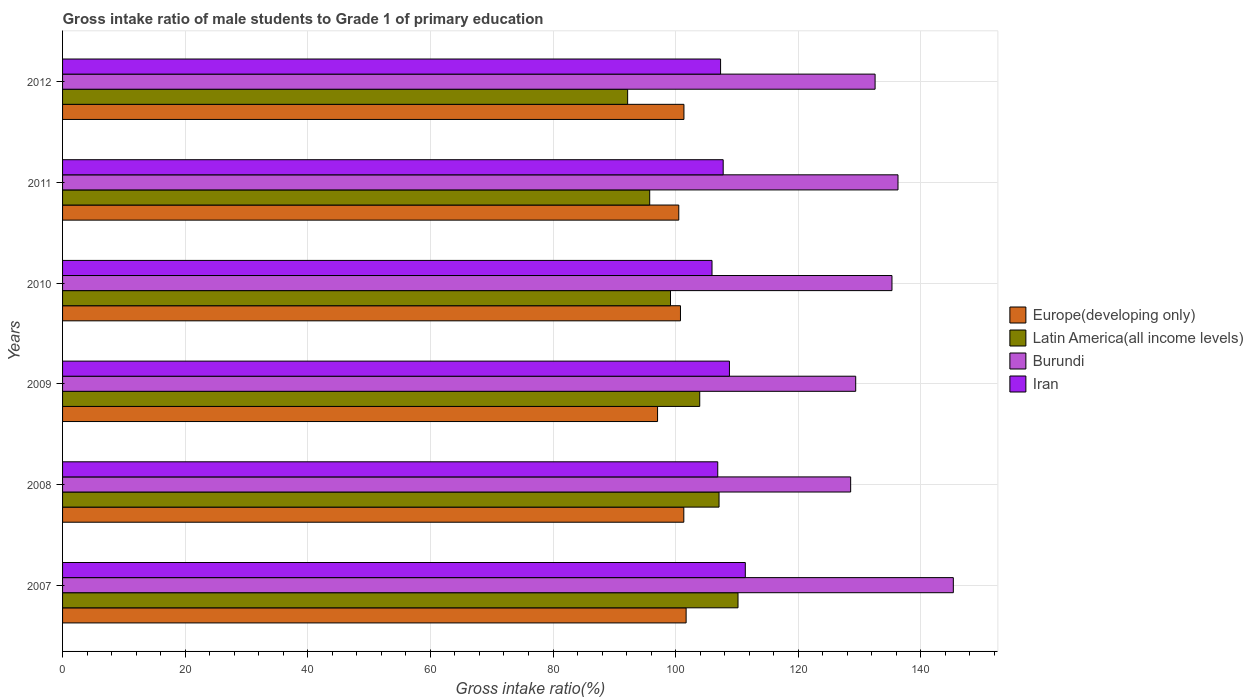How many different coloured bars are there?
Offer a terse response. 4. How many bars are there on the 2nd tick from the top?
Keep it short and to the point. 4. How many bars are there on the 3rd tick from the bottom?
Your answer should be very brief. 4. What is the gross intake ratio in Iran in 2009?
Your answer should be very brief. 108.78. Across all years, what is the maximum gross intake ratio in Latin America(all income levels)?
Give a very brief answer. 110.18. Across all years, what is the minimum gross intake ratio in Europe(developing only)?
Offer a very short reply. 97.05. In which year was the gross intake ratio in Latin America(all income levels) maximum?
Make the answer very short. 2007. What is the total gross intake ratio in Latin America(all income levels) in the graph?
Ensure brevity in your answer.  608.3. What is the difference between the gross intake ratio in Latin America(all income levels) in 2007 and that in 2011?
Give a very brief answer. 14.4. What is the difference between the gross intake ratio in Europe(developing only) in 2010 and the gross intake ratio in Iran in 2008?
Your answer should be compact. -6.08. What is the average gross intake ratio in Europe(developing only) per year?
Provide a succinct answer. 100.46. In the year 2007, what is the difference between the gross intake ratio in Europe(developing only) and gross intake ratio in Burundi?
Offer a very short reply. -43.58. What is the ratio of the gross intake ratio in Latin America(all income levels) in 2007 to that in 2008?
Offer a terse response. 1.03. What is the difference between the highest and the second highest gross intake ratio in Iran?
Provide a succinct answer. 2.59. What is the difference between the highest and the lowest gross intake ratio in Latin America(all income levels)?
Your response must be concise. 18. In how many years, is the gross intake ratio in Burundi greater than the average gross intake ratio in Burundi taken over all years?
Give a very brief answer. 3. Is the sum of the gross intake ratio in Latin America(all income levels) in 2007 and 2009 greater than the maximum gross intake ratio in Burundi across all years?
Your response must be concise. Yes. What does the 4th bar from the top in 2008 represents?
Provide a succinct answer. Europe(developing only). What does the 1st bar from the bottom in 2010 represents?
Ensure brevity in your answer.  Europe(developing only). Is it the case that in every year, the sum of the gross intake ratio in Burundi and gross intake ratio in Latin America(all income levels) is greater than the gross intake ratio in Europe(developing only)?
Keep it short and to the point. Yes. How many bars are there?
Ensure brevity in your answer.  24. Are the values on the major ticks of X-axis written in scientific E-notation?
Offer a very short reply. No. Does the graph contain grids?
Your answer should be very brief. Yes. How are the legend labels stacked?
Provide a short and direct response. Vertical. What is the title of the graph?
Your answer should be very brief. Gross intake ratio of male students to Grade 1 of primary education. Does "St. Lucia" appear as one of the legend labels in the graph?
Offer a very short reply. No. What is the label or title of the X-axis?
Offer a terse response. Gross intake ratio(%). What is the Gross intake ratio(%) in Europe(developing only) in 2007?
Provide a short and direct response. 101.71. What is the Gross intake ratio(%) of Latin America(all income levels) in 2007?
Offer a very short reply. 110.18. What is the Gross intake ratio(%) of Burundi in 2007?
Offer a very short reply. 145.3. What is the Gross intake ratio(%) of Iran in 2007?
Make the answer very short. 111.37. What is the Gross intake ratio(%) of Europe(developing only) in 2008?
Your answer should be very brief. 101.34. What is the Gross intake ratio(%) in Latin America(all income levels) in 2008?
Your answer should be very brief. 107.08. What is the Gross intake ratio(%) in Burundi in 2008?
Ensure brevity in your answer.  128.55. What is the Gross intake ratio(%) of Iran in 2008?
Your answer should be very brief. 106.87. What is the Gross intake ratio(%) in Europe(developing only) in 2009?
Your response must be concise. 97.05. What is the Gross intake ratio(%) in Latin America(all income levels) in 2009?
Ensure brevity in your answer.  103.93. What is the Gross intake ratio(%) in Burundi in 2009?
Make the answer very short. 129.37. What is the Gross intake ratio(%) in Iran in 2009?
Your response must be concise. 108.78. What is the Gross intake ratio(%) in Europe(developing only) in 2010?
Ensure brevity in your answer.  100.79. What is the Gross intake ratio(%) of Latin America(all income levels) in 2010?
Ensure brevity in your answer.  99.16. What is the Gross intake ratio(%) in Burundi in 2010?
Offer a terse response. 135.29. What is the Gross intake ratio(%) of Iran in 2010?
Give a very brief answer. 105.94. What is the Gross intake ratio(%) in Europe(developing only) in 2011?
Provide a short and direct response. 100.51. What is the Gross intake ratio(%) of Latin America(all income levels) in 2011?
Make the answer very short. 95.77. What is the Gross intake ratio(%) of Burundi in 2011?
Your response must be concise. 136.27. What is the Gross intake ratio(%) in Iran in 2011?
Provide a short and direct response. 107.76. What is the Gross intake ratio(%) of Europe(developing only) in 2012?
Keep it short and to the point. 101.36. What is the Gross intake ratio(%) in Latin America(all income levels) in 2012?
Make the answer very short. 92.17. What is the Gross intake ratio(%) of Burundi in 2012?
Offer a terse response. 132.54. What is the Gross intake ratio(%) in Iran in 2012?
Your answer should be compact. 107.33. Across all years, what is the maximum Gross intake ratio(%) of Europe(developing only)?
Offer a very short reply. 101.71. Across all years, what is the maximum Gross intake ratio(%) in Latin America(all income levels)?
Offer a terse response. 110.18. Across all years, what is the maximum Gross intake ratio(%) of Burundi?
Your response must be concise. 145.3. Across all years, what is the maximum Gross intake ratio(%) of Iran?
Your answer should be compact. 111.37. Across all years, what is the minimum Gross intake ratio(%) of Europe(developing only)?
Give a very brief answer. 97.05. Across all years, what is the minimum Gross intake ratio(%) in Latin America(all income levels)?
Offer a terse response. 92.17. Across all years, what is the minimum Gross intake ratio(%) of Burundi?
Give a very brief answer. 128.55. Across all years, what is the minimum Gross intake ratio(%) in Iran?
Your answer should be compact. 105.94. What is the total Gross intake ratio(%) in Europe(developing only) in the graph?
Provide a succinct answer. 602.77. What is the total Gross intake ratio(%) in Latin America(all income levels) in the graph?
Give a very brief answer. 608.3. What is the total Gross intake ratio(%) of Burundi in the graph?
Your answer should be very brief. 807.32. What is the total Gross intake ratio(%) in Iran in the graph?
Your answer should be compact. 648.04. What is the difference between the Gross intake ratio(%) in Europe(developing only) in 2007 and that in 2008?
Your answer should be compact. 0.38. What is the difference between the Gross intake ratio(%) in Latin America(all income levels) in 2007 and that in 2008?
Give a very brief answer. 3.1. What is the difference between the Gross intake ratio(%) of Burundi in 2007 and that in 2008?
Give a very brief answer. 16.75. What is the difference between the Gross intake ratio(%) of Iran in 2007 and that in 2008?
Your answer should be compact. 4.5. What is the difference between the Gross intake ratio(%) in Europe(developing only) in 2007 and that in 2009?
Your response must be concise. 4.66. What is the difference between the Gross intake ratio(%) in Latin America(all income levels) in 2007 and that in 2009?
Your answer should be very brief. 6.25. What is the difference between the Gross intake ratio(%) in Burundi in 2007 and that in 2009?
Your answer should be compact. 15.92. What is the difference between the Gross intake ratio(%) of Iran in 2007 and that in 2009?
Keep it short and to the point. 2.59. What is the difference between the Gross intake ratio(%) in Europe(developing only) in 2007 and that in 2010?
Offer a very short reply. 0.92. What is the difference between the Gross intake ratio(%) of Latin America(all income levels) in 2007 and that in 2010?
Provide a short and direct response. 11.01. What is the difference between the Gross intake ratio(%) in Burundi in 2007 and that in 2010?
Provide a succinct answer. 10.01. What is the difference between the Gross intake ratio(%) in Iran in 2007 and that in 2010?
Offer a terse response. 5.43. What is the difference between the Gross intake ratio(%) in Europe(developing only) in 2007 and that in 2011?
Provide a succinct answer. 1.2. What is the difference between the Gross intake ratio(%) of Latin America(all income levels) in 2007 and that in 2011?
Offer a terse response. 14.4. What is the difference between the Gross intake ratio(%) in Burundi in 2007 and that in 2011?
Give a very brief answer. 9.03. What is the difference between the Gross intake ratio(%) of Iran in 2007 and that in 2011?
Keep it short and to the point. 3.61. What is the difference between the Gross intake ratio(%) of Europe(developing only) in 2007 and that in 2012?
Provide a short and direct response. 0.36. What is the difference between the Gross intake ratio(%) of Latin America(all income levels) in 2007 and that in 2012?
Keep it short and to the point. 18. What is the difference between the Gross intake ratio(%) of Burundi in 2007 and that in 2012?
Your response must be concise. 12.76. What is the difference between the Gross intake ratio(%) in Iran in 2007 and that in 2012?
Keep it short and to the point. 4.03. What is the difference between the Gross intake ratio(%) in Europe(developing only) in 2008 and that in 2009?
Keep it short and to the point. 4.28. What is the difference between the Gross intake ratio(%) of Latin America(all income levels) in 2008 and that in 2009?
Keep it short and to the point. 3.15. What is the difference between the Gross intake ratio(%) of Burundi in 2008 and that in 2009?
Make the answer very short. -0.82. What is the difference between the Gross intake ratio(%) in Iran in 2008 and that in 2009?
Your answer should be very brief. -1.91. What is the difference between the Gross intake ratio(%) in Europe(developing only) in 2008 and that in 2010?
Offer a terse response. 0.54. What is the difference between the Gross intake ratio(%) in Latin America(all income levels) in 2008 and that in 2010?
Your answer should be compact. 7.92. What is the difference between the Gross intake ratio(%) of Burundi in 2008 and that in 2010?
Offer a very short reply. -6.74. What is the difference between the Gross intake ratio(%) in Iran in 2008 and that in 2010?
Keep it short and to the point. 0.93. What is the difference between the Gross intake ratio(%) in Europe(developing only) in 2008 and that in 2011?
Make the answer very short. 0.82. What is the difference between the Gross intake ratio(%) in Latin America(all income levels) in 2008 and that in 2011?
Your response must be concise. 11.31. What is the difference between the Gross intake ratio(%) in Burundi in 2008 and that in 2011?
Your answer should be very brief. -7.72. What is the difference between the Gross intake ratio(%) in Iran in 2008 and that in 2011?
Provide a succinct answer. -0.89. What is the difference between the Gross intake ratio(%) of Europe(developing only) in 2008 and that in 2012?
Keep it short and to the point. -0.02. What is the difference between the Gross intake ratio(%) of Latin America(all income levels) in 2008 and that in 2012?
Provide a short and direct response. 14.91. What is the difference between the Gross intake ratio(%) in Burundi in 2008 and that in 2012?
Provide a succinct answer. -3.99. What is the difference between the Gross intake ratio(%) in Iran in 2008 and that in 2012?
Your answer should be very brief. -0.46. What is the difference between the Gross intake ratio(%) in Europe(developing only) in 2009 and that in 2010?
Your answer should be compact. -3.74. What is the difference between the Gross intake ratio(%) of Latin America(all income levels) in 2009 and that in 2010?
Keep it short and to the point. 4.77. What is the difference between the Gross intake ratio(%) in Burundi in 2009 and that in 2010?
Offer a terse response. -5.92. What is the difference between the Gross intake ratio(%) in Iran in 2009 and that in 2010?
Make the answer very short. 2.84. What is the difference between the Gross intake ratio(%) in Europe(developing only) in 2009 and that in 2011?
Keep it short and to the point. -3.46. What is the difference between the Gross intake ratio(%) in Latin America(all income levels) in 2009 and that in 2011?
Provide a succinct answer. 8.16. What is the difference between the Gross intake ratio(%) of Burundi in 2009 and that in 2011?
Offer a very short reply. -6.9. What is the difference between the Gross intake ratio(%) of Iran in 2009 and that in 2011?
Your answer should be very brief. 1.02. What is the difference between the Gross intake ratio(%) in Europe(developing only) in 2009 and that in 2012?
Offer a terse response. -4.3. What is the difference between the Gross intake ratio(%) in Latin America(all income levels) in 2009 and that in 2012?
Your answer should be compact. 11.76. What is the difference between the Gross intake ratio(%) of Burundi in 2009 and that in 2012?
Provide a succinct answer. -3.16. What is the difference between the Gross intake ratio(%) of Iran in 2009 and that in 2012?
Keep it short and to the point. 1.45. What is the difference between the Gross intake ratio(%) in Europe(developing only) in 2010 and that in 2011?
Ensure brevity in your answer.  0.28. What is the difference between the Gross intake ratio(%) in Latin America(all income levels) in 2010 and that in 2011?
Provide a short and direct response. 3.39. What is the difference between the Gross intake ratio(%) in Burundi in 2010 and that in 2011?
Your answer should be very brief. -0.98. What is the difference between the Gross intake ratio(%) of Iran in 2010 and that in 2011?
Offer a terse response. -1.82. What is the difference between the Gross intake ratio(%) in Europe(developing only) in 2010 and that in 2012?
Ensure brevity in your answer.  -0.57. What is the difference between the Gross intake ratio(%) in Latin America(all income levels) in 2010 and that in 2012?
Offer a very short reply. 6.99. What is the difference between the Gross intake ratio(%) in Burundi in 2010 and that in 2012?
Give a very brief answer. 2.75. What is the difference between the Gross intake ratio(%) in Iran in 2010 and that in 2012?
Ensure brevity in your answer.  -1.4. What is the difference between the Gross intake ratio(%) in Europe(developing only) in 2011 and that in 2012?
Ensure brevity in your answer.  -0.84. What is the difference between the Gross intake ratio(%) of Latin America(all income levels) in 2011 and that in 2012?
Make the answer very short. 3.6. What is the difference between the Gross intake ratio(%) of Burundi in 2011 and that in 2012?
Keep it short and to the point. 3.74. What is the difference between the Gross intake ratio(%) of Iran in 2011 and that in 2012?
Your answer should be very brief. 0.43. What is the difference between the Gross intake ratio(%) of Europe(developing only) in 2007 and the Gross intake ratio(%) of Latin America(all income levels) in 2008?
Offer a very short reply. -5.37. What is the difference between the Gross intake ratio(%) of Europe(developing only) in 2007 and the Gross intake ratio(%) of Burundi in 2008?
Provide a short and direct response. -26.84. What is the difference between the Gross intake ratio(%) in Europe(developing only) in 2007 and the Gross intake ratio(%) in Iran in 2008?
Offer a very short reply. -5.16. What is the difference between the Gross intake ratio(%) of Latin America(all income levels) in 2007 and the Gross intake ratio(%) of Burundi in 2008?
Your answer should be compact. -18.37. What is the difference between the Gross intake ratio(%) in Latin America(all income levels) in 2007 and the Gross intake ratio(%) in Iran in 2008?
Provide a short and direct response. 3.31. What is the difference between the Gross intake ratio(%) of Burundi in 2007 and the Gross intake ratio(%) of Iran in 2008?
Give a very brief answer. 38.43. What is the difference between the Gross intake ratio(%) in Europe(developing only) in 2007 and the Gross intake ratio(%) in Latin America(all income levels) in 2009?
Provide a short and direct response. -2.22. What is the difference between the Gross intake ratio(%) in Europe(developing only) in 2007 and the Gross intake ratio(%) in Burundi in 2009?
Ensure brevity in your answer.  -27.66. What is the difference between the Gross intake ratio(%) of Europe(developing only) in 2007 and the Gross intake ratio(%) of Iran in 2009?
Your response must be concise. -7.07. What is the difference between the Gross intake ratio(%) of Latin America(all income levels) in 2007 and the Gross intake ratio(%) of Burundi in 2009?
Your answer should be very brief. -19.2. What is the difference between the Gross intake ratio(%) in Latin America(all income levels) in 2007 and the Gross intake ratio(%) in Iran in 2009?
Give a very brief answer. 1.4. What is the difference between the Gross intake ratio(%) in Burundi in 2007 and the Gross intake ratio(%) in Iran in 2009?
Your response must be concise. 36.52. What is the difference between the Gross intake ratio(%) of Europe(developing only) in 2007 and the Gross intake ratio(%) of Latin America(all income levels) in 2010?
Provide a succinct answer. 2.55. What is the difference between the Gross intake ratio(%) of Europe(developing only) in 2007 and the Gross intake ratio(%) of Burundi in 2010?
Offer a very short reply. -33.58. What is the difference between the Gross intake ratio(%) in Europe(developing only) in 2007 and the Gross intake ratio(%) in Iran in 2010?
Your response must be concise. -4.22. What is the difference between the Gross intake ratio(%) in Latin America(all income levels) in 2007 and the Gross intake ratio(%) in Burundi in 2010?
Keep it short and to the point. -25.11. What is the difference between the Gross intake ratio(%) in Latin America(all income levels) in 2007 and the Gross intake ratio(%) in Iran in 2010?
Give a very brief answer. 4.24. What is the difference between the Gross intake ratio(%) in Burundi in 2007 and the Gross intake ratio(%) in Iran in 2010?
Ensure brevity in your answer.  39.36. What is the difference between the Gross intake ratio(%) of Europe(developing only) in 2007 and the Gross intake ratio(%) of Latin America(all income levels) in 2011?
Offer a very short reply. 5.94. What is the difference between the Gross intake ratio(%) of Europe(developing only) in 2007 and the Gross intake ratio(%) of Burundi in 2011?
Give a very brief answer. -34.56. What is the difference between the Gross intake ratio(%) of Europe(developing only) in 2007 and the Gross intake ratio(%) of Iran in 2011?
Keep it short and to the point. -6.05. What is the difference between the Gross intake ratio(%) in Latin America(all income levels) in 2007 and the Gross intake ratio(%) in Burundi in 2011?
Ensure brevity in your answer.  -26.1. What is the difference between the Gross intake ratio(%) in Latin America(all income levels) in 2007 and the Gross intake ratio(%) in Iran in 2011?
Ensure brevity in your answer.  2.42. What is the difference between the Gross intake ratio(%) in Burundi in 2007 and the Gross intake ratio(%) in Iran in 2011?
Keep it short and to the point. 37.54. What is the difference between the Gross intake ratio(%) in Europe(developing only) in 2007 and the Gross intake ratio(%) in Latin America(all income levels) in 2012?
Your response must be concise. 9.54. What is the difference between the Gross intake ratio(%) of Europe(developing only) in 2007 and the Gross intake ratio(%) of Burundi in 2012?
Keep it short and to the point. -30.82. What is the difference between the Gross intake ratio(%) of Europe(developing only) in 2007 and the Gross intake ratio(%) of Iran in 2012?
Keep it short and to the point. -5.62. What is the difference between the Gross intake ratio(%) in Latin America(all income levels) in 2007 and the Gross intake ratio(%) in Burundi in 2012?
Your answer should be compact. -22.36. What is the difference between the Gross intake ratio(%) in Latin America(all income levels) in 2007 and the Gross intake ratio(%) in Iran in 2012?
Your response must be concise. 2.85. What is the difference between the Gross intake ratio(%) in Burundi in 2007 and the Gross intake ratio(%) in Iran in 2012?
Offer a terse response. 37.97. What is the difference between the Gross intake ratio(%) in Europe(developing only) in 2008 and the Gross intake ratio(%) in Latin America(all income levels) in 2009?
Keep it short and to the point. -2.6. What is the difference between the Gross intake ratio(%) of Europe(developing only) in 2008 and the Gross intake ratio(%) of Burundi in 2009?
Offer a very short reply. -28.04. What is the difference between the Gross intake ratio(%) in Europe(developing only) in 2008 and the Gross intake ratio(%) in Iran in 2009?
Provide a succinct answer. -7.44. What is the difference between the Gross intake ratio(%) of Latin America(all income levels) in 2008 and the Gross intake ratio(%) of Burundi in 2009?
Offer a very short reply. -22.29. What is the difference between the Gross intake ratio(%) of Latin America(all income levels) in 2008 and the Gross intake ratio(%) of Iran in 2009?
Your response must be concise. -1.7. What is the difference between the Gross intake ratio(%) of Burundi in 2008 and the Gross intake ratio(%) of Iran in 2009?
Ensure brevity in your answer.  19.77. What is the difference between the Gross intake ratio(%) of Europe(developing only) in 2008 and the Gross intake ratio(%) of Latin America(all income levels) in 2010?
Your response must be concise. 2.17. What is the difference between the Gross intake ratio(%) in Europe(developing only) in 2008 and the Gross intake ratio(%) in Burundi in 2010?
Ensure brevity in your answer.  -33.95. What is the difference between the Gross intake ratio(%) of Europe(developing only) in 2008 and the Gross intake ratio(%) of Iran in 2010?
Offer a terse response. -4.6. What is the difference between the Gross intake ratio(%) of Latin America(all income levels) in 2008 and the Gross intake ratio(%) of Burundi in 2010?
Your response must be concise. -28.21. What is the difference between the Gross intake ratio(%) of Latin America(all income levels) in 2008 and the Gross intake ratio(%) of Iran in 2010?
Make the answer very short. 1.15. What is the difference between the Gross intake ratio(%) of Burundi in 2008 and the Gross intake ratio(%) of Iran in 2010?
Offer a terse response. 22.61. What is the difference between the Gross intake ratio(%) of Europe(developing only) in 2008 and the Gross intake ratio(%) of Latin America(all income levels) in 2011?
Offer a very short reply. 5.56. What is the difference between the Gross intake ratio(%) in Europe(developing only) in 2008 and the Gross intake ratio(%) in Burundi in 2011?
Provide a succinct answer. -34.94. What is the difference between the Gross intake ratio(%) of Europe(developing only) in 2008 and the Gross intake ratio(%) of Iran in 2011?
Offer a terse response. -6.42. What is the difference between the Gross intake ratio(%) in Latin America(all income levels) in 2008 and the Gross intake ratio(%) in Burundi in 2011?
Ensure brevity in your answer.  -29.19. What is the difference between the Gross intake ratio(%) of Latin America(all income levels) in 2008 and the Gross intake ratio(%) of Iran in 2011?
Offer a terse response. -0.68. What is the difference between the Gross intake ratio(%) of Burundi in 2008 and the Gross intake ratio(%) of Iran in 2011?
Make the answer very short. 20.79. What is the difference between the Gross intake ratio(%) in Europe(developing only) in 2008 and the Gross intake ratio(%) in Latin America(all income levels) in 2012?
Give a very brief answer. 9.16. What is the difference between the Gross intake ratio(%) in Europe(developing only) in 2008 and the Gross intake ratio(%) in Burundi in 2012?
Your answer should be compact. -31.2. What is the difference between the Gross intake ratio(%) of Europe(developing only) in 2008 and the Gross intake ratio(%) of Iran in 2012?
Keep it short and to the point. -6. What is the difference between the Gross intake ratio(%) of Latin America(all income levels) in 2008 and the Gross intake ratio(%) of Burundi in 2012?
Make the answer very short. -25.46. What is the difference between the Gross intake ratio(%) in Latin America(all income levels) in 2008 and the Gross intake ratio(%) in Iran in 2012?
Provide a succinct answer. -0.25. What is the difference between the Gross intake ratio(%) of Burundi in 2008 and the Gross intake ratio(%) of Iran in 2012?
Your answer should be compact. 21.22. What is the difference between the Gross intake ratio(%) of Europe(developing only) in 2009 and the Gross intake ratio(%) of Latin America(all income levels) in 2010?
Provide a succinct answer. -2.11. What is the difference between the Gross intake ratio(%) in Europe(developing only) in 2009 and the Gross intake ratio(%) in Burundi in 2010?
Your answer should be very brief. -38.24. What is the difference between the Gross intake ratio(%) in Europe(developing only) in 2009 and the Gross intake ratio(%) in Iran in 2010?
Your answer should be compact. -8.88. What is the difference between the Gross intake ratio(%) of Latin America(all income levels) in 2009 and the Gross intake ratio(%) of Burundi in 2010?
Your answer should be very brief. -31.36. What is the difference between the Gross intake ratio(%) of Latin America(all income levels) in 2009 and the Gross intake ratio(%) of Iran in 2010?
Keep it short and to the point. -2. What is the difference between the Gross intake ratio(%) in Burundi in 2009 and the Gross intake ratio(%) in Iran in 2010?
Your answer should be compact. 23.44. What is the difference between the Gross intake ratio(%) in Europe(developing only) in 2009 and the Gross intake ratio(%) in Latin America(all income levels) in 2011?
Ensure brevity in your answer.  1.28. What is the difference between the Gross intake ratio(%) in Europe(developing only) in 2009 and the Gross intake ratio(%) in Burundi in 2011?
Make the answer very short. -39.22. What is the difference between the Gross intake ratio(%) in Europe(developing only) in 2009 and the Gross intake ratio(%) in Iran in 2011?
Provide a succinct answer. -10.7. What is the difference between the Gross intake ratio(%) of Latin America(all income levels) in 2009 and the Gross intake ratio(%) of Burundi in 2011?
Offer a very short reply. -32.34. What is the difference between the Gross intake ratio(%) in Latin America(all income levels) in 2009 and the Gross intake ratio(%) in Iran in 2011?
Make the answer very short. -3.83. What is the difference between the Gross intake ratio(%) in Burundi in 2009 and the Gross intake ratio(%) in Iran in 2011?
Provide a succinct answer. 21.62. What is the difference between the Gross intake ratio(%) of Europe(developing only) in 2009 and the Gross intake ratio(%) of Latin America(all income levels) in 2012?
Provide a short and direct response. 4.88. What is the difference between the Gross intake ratio(%) in Europe(developing only) in 2009 and the Gross intake ratio(%) in Burundi in 2012?
Offer a very short reply. -35.48. What is the difference between the Gross intake ratio(%) of Europe(developing only) in 2009 and the Gross intake ratio(%) of Iran in 2012?
Offer a terse response. -10.28. What is the difference between the Gross intake ratio(%) in Latin America(all income levels) in 2009 and the Gross intake ratio(%) in Burundi in 2012?
Your response must be concise. -28.61. What is the difference between the Gross intake ratio(%) in Latin America(all income levels) in 2009 and the Gross intake ratio(%) in Iran in 2012?
Give a very brief answer. -3.4. What is the difference between the Gross intake ratio(%) of Burundi in 2009 and the Gross intake ratio(%) of Iran in 2012?
Make the answer very short. 22.04. What is the difference between the Gross intake ratio(%) in Europe(developing only) in 2010 and the Gross intake ratio(%) in Latin America(all income levels) in 2011?
Keep it short and to the point. 5.02. What is the difference between the Gross intake ratio(%) of Europe(developing only) in 2010 and the Gross intake ratio(%) of Burundi in 2011?
Ensure brevity in your answer.  -35.48. What is the difference between the Gross intake ratio(%) in Europe(developing only) in 2010 and the Gross intake ratio(%) in Iran in 2011?
Ensure brevity in your answer.  -6.97. What is the difference between the Gross intake ratio(%) in Latin America(all income levels) in 2010 and the Gross intake ratio(%) in Burundi in 2011?
Provide a succinct answer. -37.11. What is the difference between the Gross intake ratio(%) of Latin America(all income levels) in 2010 and the Gross intake ratio(%) of Iran in 2011?
Your response must be concise. -8.59. What is the difference between the Gross intake ratio(%) of Burundi in 2010 and the Gross intake ratio(%) of Iran in 2011?
Offer a terse response. 27.53. What is the difference between the Gross intake ratio(%) of Europe(developing only) in 2010 and the Gross intake ratio(%) of Latin America(all income levels) in 2012?
Your answer should be compact. 8.62. What is the difference between the Gross intake ratio(%) in Europe(developing only) in 2010 and the Gross intake ratio(%) in Burundi in 2012?
Ensure brevity in your answer.  -31.75. What is the difference between the Gross intake ratio(%) in Europe(developing only) in 2010 and the Gross intake ratio(%) in Iran in 2012?
Keep it short and to the point. -6.54. What is the difference between the Gross intake ratio(%) in Latin America(all income levels) in 2010 and the Gross intake ratio(%) in Burundi in 2012?
Keep it short and to the point. -33.37. What is the difference between the Gross intake ratio(%) of Latin America(all income levels) in 2010 and the Gross intake ratio(%) of Iran in 2012?
Your answer should be compact. -8.17. What is the difference between the Gross intake ratio(%) of Burundi in 2010 and the Gross intake ratio(%) of Iran in 2012?
Your answer should be very brief. 27.96. What is the difference between the Gross intake ratio(%) in Europe(developing only) in 2011 and the Gross intake ratio(%) in Latin America(all income levels) in 2012?
Give a very brief answer. 8.34. What is the difference between the Gross intake ratio(%) of Europe(developing only) in 2011 and the Gross intake ratio(%) of Burundi in 2012?
Offer a terse response. -32.02. What is the difference between the Gross intake ratio(%) in Europe(developing only) in 2011 and the Gross intake ratio(%) in Iran in 2012?
Your answer should be very brief. -6.82. What is the difference between the Gross intake ratio(%) of Latin America(all income levels) in 2011 and the Gross intake ratio(%) of Burundi in 2012?
Provide a succinct answer. -36.76. What is the difference between the Gross intake ratio(%) in Latin America(all income levels) in 2011 and the Gross intake ratio(%) in Iran in 2012?
Make the answer very short. -11.56. What is the difference between the Gross intake ratio(%) in Burundi in 2011 and the Gross intake ratio(%) in Iran in 2012?
Keep it short and to the point. 28.94. What is the average Gross intake ratio(%) in Europe(developing only) per year?
Make the answer very short. 100.46. What is the average Gross intake ratio(%) in Latin America(all income levels) per year?
Your answer should be very brief. 101.38. What is the average Gross intake ratio(%) in Burundi per year?
Ensure brevity in your answer.  134.55. What is the average Gross intake ratio(%) of Iran per year?
Provide a short and direct response. 108.01. In the year 2007, what is the difference between the Gross intake ratio(%) in Europe(developing only) and Gross intake ratio(%) in Latin America(all income levels)?
Your answer should be compact. -8.46. In the year 2007, what is the difference between the Gross intake ratio(%) in Europe(developing only) and Gross intake ratio(%) in Burundi?
Make the answer very short. -43.58. In the year 2007, what is the difference between the Gross intake ratio(%) of Europe(developing only) and Gross intake ratio(%) of Iran?
Provide a short and direct response. -9.65. In the year 2007, what is the difference between the Gross intake ratio(%) in Latin America(all income levels) and Gross intake ratio(%) in Burundi?
Offer a very short reply. -35.12. In the year 2007, what is the difference between the Gross intake ratio(%) in Latin America(all income levels) and Gross intake ratio(%) in Iran?
Provide a succinct answer. -1.19. In the year 2007, what is the difference between the Gross intake ratio(%) of Burundi and Gross intake ratio(%) of Iran?
Give a very brief answer. 33.93. In the year 2008, what is the difference between the Gross intake ratio(%) in Europe(developing only) and Gross intake ratio(%) in Latin America(all income levels)?
Keep it short and to the point. -5.75. In the year 2008, what is the difference between the Gross intake ratio(%) of Europe(developing only) and Gross intake ratio(%) of Burundi?
Offer a terse response. -27.22. In the year 2008, what is the difference between the Gross intake ratio(%) of Europe(developing only) and Gross intake ratio(%) of Iran?
Your answer should be very brief. -5.53. In the year 2008, what is the difference between the Gross intake ratio(%) in Latin America(all income levels) and Gross intake ratio(%) in Burundi?
Keep it short and to the point. -21.47. In the year 2008, what is the difference between the Gross intake ratio(%) in Latin America(all income levels) and Gross intake ratio(%) in Iran?
Provide a succinct answer. 0.21. In the year 2008, what is the difference between the Gross intake ratio(%) of Burundi and Gross intake ratio(%) of Iran?
Your answer should be very brief. 21.68. In the year 2009, what is the difference between the Gross intake ratio(%) in Europe(developing only) and Gross intake ratio(%) in Latin America(all income levels)?
Your answer should be compact. -6.88. In the year 2009, what is the difference between the Gross intake ratio(%) in Europe(developing only) and Gross intake ratio(%) in Burundi?
Provide a short and direct response. -32.32. In the year 2009, what is the difference between the Gross intake ratio(%) in Europe(developing only) and Gross intake ratio(%) in Iran?
Your answer should be compact. -11.72. In the year 2009, what is the difference between the Gross intake ratio(%) in Latin America(all income levels) and Gross intake ratio(%) in Burundi?
Provide a succinct answer. -25.44. In the year 2009, what is the difference between the Gross intake ratio(%) of Latin America(all income levels) and Gross intake ratio(%) of Iran?
Your answer should be very brief. -4.85. In the year 2009, what is the difference between the Gross intake ratio(%) in Burundi and Gross intake ratio(%) in Iran?
Offer a very short reply. 20.6. In the year 2010, what is the difference between the Gross intake ratio(%) in Europe(developing only) and Gross intake ratio(%) in Latin America(all income levels)?
Offer a terse response. 1.63. In the year 2010, what is the difference between the Gross intake ratio(%) in Europe(developing only) and Gross intake ratio(%) in Burundi?
Your response must be concise. -34.5. In the year 2010, what is the difference between the Gross intake ratio(%) in Europe(developing only) and Gross intake ratio(%) in Iran?
Your answer should be compact. -5.15. In the year 2010, what is the difference between the Gross intake ratio(%) in Latin America(all income levels) and Gross intake ratio(%) in Burundi?
Your answer should be compact. -36.13. In the year 2010, what is the difference between the Gross intake ratio(%) of Latin America(all income levels) and Gross intake ratio(%) of Iran?
Your answer should be compact. -6.77. In the year 2010, what is the difference between the Gross intake ratio(%) of Burundi and Gross intake ratio(%) of Iran?
Ensure brevity in your answer.  29.35. In the year 2011, what is the difference between the Gross intake ratio(%) of Europe(developing only) and Gross intake ratio(%) of Latin America(all income levels)?
Keep it short and to the point. 4.74. In the year 2011, what is the difference between the Gross intake ratio(%) of Europe(developing only) and Gross intake ratio(%) of Burundi?
Give a very brief answer. -35.76. In the year 2011, what is the difference between the Gross intake ratio(%) of Europe(developing only) and Gross intake ratio(%) of Iran?
Your answer should be compact. -7.24. In the year 2011, what is the difference between the Gross intake ratio(%) in Latin America(all income levels) and Gross intake ratio(%) in Burundi?
Keep it short and to the point. -40.5. In the year 2011, what is the difference between the Gross intake ratio(%) in Latin America(all income levels) and Gross intake ratio(%) in Iran?
Make the answer very short. -11.99. In the year 2011, what is the difference between the Gross intake ratio(%) of Burundi and Gross intake ratio(%) of Iran?
Provide a succinct answer. 28.51. In the year 2012, what is the difference between the Gross intake ratio(%) of Europe(developing only) and Gross intake ratio(%) of Latin America(all income levels)?
Your response must be concise. 9.18. In the year 2012, what is the difference between the Gross intake ratio(%) of Europe(developing only) and Gross intake ratio(%) of Burundi?
Offer a terse response. -31.18. In the year 2012, what is the difference between the Gross intake ratio(%) in Europe(developing only) and Gross intake ratio(%) in Iran?
Offer a terse response. -5.98. In the year 2012, what is the difference between the Gross intake ratio(%) in Latin America(all income levels) and Gross intake ratio(%) in Burundi?
Provide a short and direct response. -40.36. In the year 2012, what is the difference between the Gross intake ratio(%) in Latin America(all income levels) and Gross intake ratio(%) in Iran?
Offer a very short reply. -15.16. In the year 2012, what is the difference between the Gross intake ratio(%) in Burundi and Gross intake ratio(%) in Iran?
Keep it short and to the point. 25.21. What is the ratio of the Gross intake ratio(%) of Europe(developing only) in 2007 to that in 2008?
Your answer should be very brief. 1. What is the ratio of the Gross intake ratio(%) in Latin America(all income levels) in 2007 to that in 2008?
Ensure brevity in your answer.  1.03. What is the ratio of the Gross intake ratio(%) in Burundi in 2007 to that in 2008?
Make the answer very short. 1.13. What is the ratio of the Gross intake ratio(%) in Iran in 2007 to that in 2008?
Make the answer very short. 1.04. What is the ratio of the Gross intake ratio(%) of Europe(developing only) in 2007 to that in 2009?
Offer a very short reply. 1.05. What is the ratio of the Gross intake ratio(%) of Latin America(all income levels) in 2007 to that in 2009?
Your response must be concise. 1.06. What is the ratio of the Gross intake ratio(%) of Burundi in 2007 to that in 2009?
Offer a very short reply. 1.12. What is the ratio of the Gross intake ratio(%) in Iran in 2007 to that in 2009?
Offer a terse response. 1.02. What is the ratio of the Gross intake ratio(%) in Europe(developing only) in 2007 to that in 2010?
Provide a short and direct response. 1.01. What is the ratio of the Gross intake ratio(%) of Burundi in 2007 to that in 2010?
Provide a short and direct response. 1.07. What is the ratio of the Gross intake ratio(%) of Iran in 2007 to that in 2010?
Ensure brevity in your answer.  1.05. What is the ratio of the Gross intake ratio(%) of Europe(developing only) in 2007 to that in 2011?
Your answer should be compact. 1.01. What is the ratio of the Gross intake ratio(%) in Latin America(all income levels) in 2007 to that in 2011?
Offer a terse response. 1.15. What is the ratio of the Gross intake ratio(%) in Burundi in 2007 to that in 2011?
Offer a very short reply. 1.07. What is the ratio of the Gross intake ratio(%) of Iran in 2007 to that in 2011?
Your answer should be compact. 1.03. What is the ratio of the Gross intake ratio(%) of Latin America(all income levels) in 2007 to that in 2012?
Your response must be concise. 1.2. What is the ratio of the Gross intake ratio(%) of Burundi in 2007 to that in 2012?
Your answer should be very brief. 1.1. What is the ratio of the Gross intake ratio(%) of Iran in 2007 to that in 2012?
Provide a short and direct response. 1.04. What is the ratio of the Gross intake ratio(%) of Europe(developing only) in 2008 to that in 2009?
Provide a succinct answer. 1.04. What is the ratio of the Gross intake ratio(%) in Latin America(all income levels) in 2008 to that in 2009?
Your answer should be compact. 1.03. What is the ratio of the Gross intake ratio(%) in Iran in 2008 to that in 2009?
Keep it short and to the point. 0.98. What is the ratio of the Gross intake ratio(%) of Europe(developing only) in 2008 to that in 2010?
Your response must be concise. 1.01. What is the ratio of the Gross intake ratio(%) in Latin America(all income levels) in 2008 to that in 2010?
Provide a succinct answer. 1.08. What is the ratio of the Gross intake ratio(%) in Burundi in 2008 to that in 2010?
Your answer should be compact. 0.95. What is the ratio of the Gross intake ratio(%) in Iran in 2008 to that in 2010?
Offer a terse response. 1.01. What is the ratio of the Gross intake ratio(%) in Europe(developing only) in 2008 to that in 2011?
Your answer should be compact. 1.01. What is the ratio of the Gross intake ratio(%) in Latin America(all income levels) in 2008 to that in 2011?
Give a very brief answer. 1.12. What is the ratio of the Gross intake ratio(%) in Burundi in 2008 to that in 2011?
Offer a very short reply. 0.94. What is the ratio of the Gross intake ratio(%) in Iran in 2008 to that in 2011?
Keep it short and to the point. 0.99. What is the ratio of the Gross intake ratio(%) of Latin America(all income levels) in 2008 to that in 2012?
Give a very brief answer. 1.16. What is the ratio of the Gross intake ratio(%) of Burundi in 2008 to that in 2012?
Provide a short and direct response. 0.97. What is the ratio of the Gross intake ratio(%) of Iran in 2008 to that in 2012?
Your response must be concise. 1. What is the ratio of the Gross intake ratio(%) in Europe(developing only) in 2009 to that in 2010?
Your answer should be compact. 0.96. What is the ratio of the Gross intake ratio(%) of Latin America(all income levels) in 2009 to that in 2010?
Provide a succinct answer. 1.05. What is the ratio of the Gross intake ratio(%) in Burundi in 2009 to that in 2010?
Provide a short and direct response. 0.96. What is the ratio of the Gross intake ratio(%) of Iran in 2009 to that in 2010?
Keep it short and to the point. 1.03. What is the ratio of the Gross intake ratio(%) of Europe(developing only) in 2009 to that in 2011?
Your response must be concise. 0.97. What is the ratio of the Gross intake ratio(%) of Latin America(all income levels) in 2009 to that in 2011?
Your answer should be compact. 1.09. What is the ratio of the Gross intake ratio(%) in Burundi in 2009 to that in 2011?
Your response must be concise. 0.95. What is the ratio of the Gross intake ratio(%) in Iran in 2009 to that in 2011?
Make the answer very short. 1.01. What is the ratio of the Gross intake ratio(%) in Europe(developing only) in 2009 to that in 2012?
Your answer should be very brief. 0.96. What is the ratio of the Gross intake ratio(%) in Latin America(all income levels) in 2009 to that in 2012?
Your answer should be compact. 1.13. What is the ratio of the Gross intake ratio(%) of Burundi in 2009 to that in 2012?
Provide a short and direct response. 0.98. What is the ratio of the Gross intake ratio(%) in Iran in 2009 to that in 2012?
Give a very brief answer. 1.01. What is the ratio of the Gross intake ratio(%) of Europe(developing only) in 2010 to that in 2011?
Make the answer very short. 1. What is the ratio of the Gross intake ratio(%) of Latin America(all income levels) in 2010 to that in 2011?
Give a very brief answer. 1.04. What is the ratio of the Gross intake ratio(%) in Burundi in 2010 to that in 2011?
Make the answer very short. 0.99. What is the ratio of the Gross intake ratio(%) of Iran in 2010 to that in 2011?
Ensure brevity in your answer.  0.98. What is the ratio of the Gross intake ratio(%) of Latin America(all income levels) in 2010 to that in 2012?
Your answer should be very brief. 1.08. What is the ratio of the Gross intake ratio(%) of Burundi in 2010 to that in 2012?
Keep it short and to the point. 1.02. What is the ratio of the Gross intake ratio(%) in Europe(developing only) in 2011 to that in 2012?
Give a very brief answer. 0.99. What is the ratio of the Gross intake ratio(%) of Latin America(all income levels) in 2011 to that in 2012?
Offer a very short reply. 1.04. What is the ratio of the Gross intake ratio(%) in Burundi in 2011 to that in 2012?
Provide a short and direct response. 1.03. What is the ratio of the Gross intake ratio(%) in Iran in 2011 to that in 2012?
Make the answer very short. 1. What is the difference between the highest and the second highest Gross intake ratio(%) of Europe(developing only)?
Keep it short and to the point. 0.36. What is the difference between the highest and the second highest Gross intake ratio(%) in Latin America(all income levels)?
Keep it short and to the point. 3.1. What is the difference between the highest and the second highest Gross intake ratio(%) in Burundi?
Ensure brevity in your answer.  9.03. What is the difference between the highest and the second highest Gross intake ratio(%) in Iran?
Offer a very short reply. 2.59. What is the difference between the highest and the lowest Gross intake ratio(%) in Europe(developing only)?
Provide a short and direct response. 4.66. What is the difference between the highest and the lowest Gross intake ratio(%) in Latin America(all income levels)?
Your answer should be very brief. 18. What is the difference between the highest and the lowest Gross intake ratio(%) of Burundi?
Make the answer very short. 16.75. What is the difference between the highest and the lowest Gross intake ratio(%) in Iran?
Ensure brevity in your answer.  5.43. 